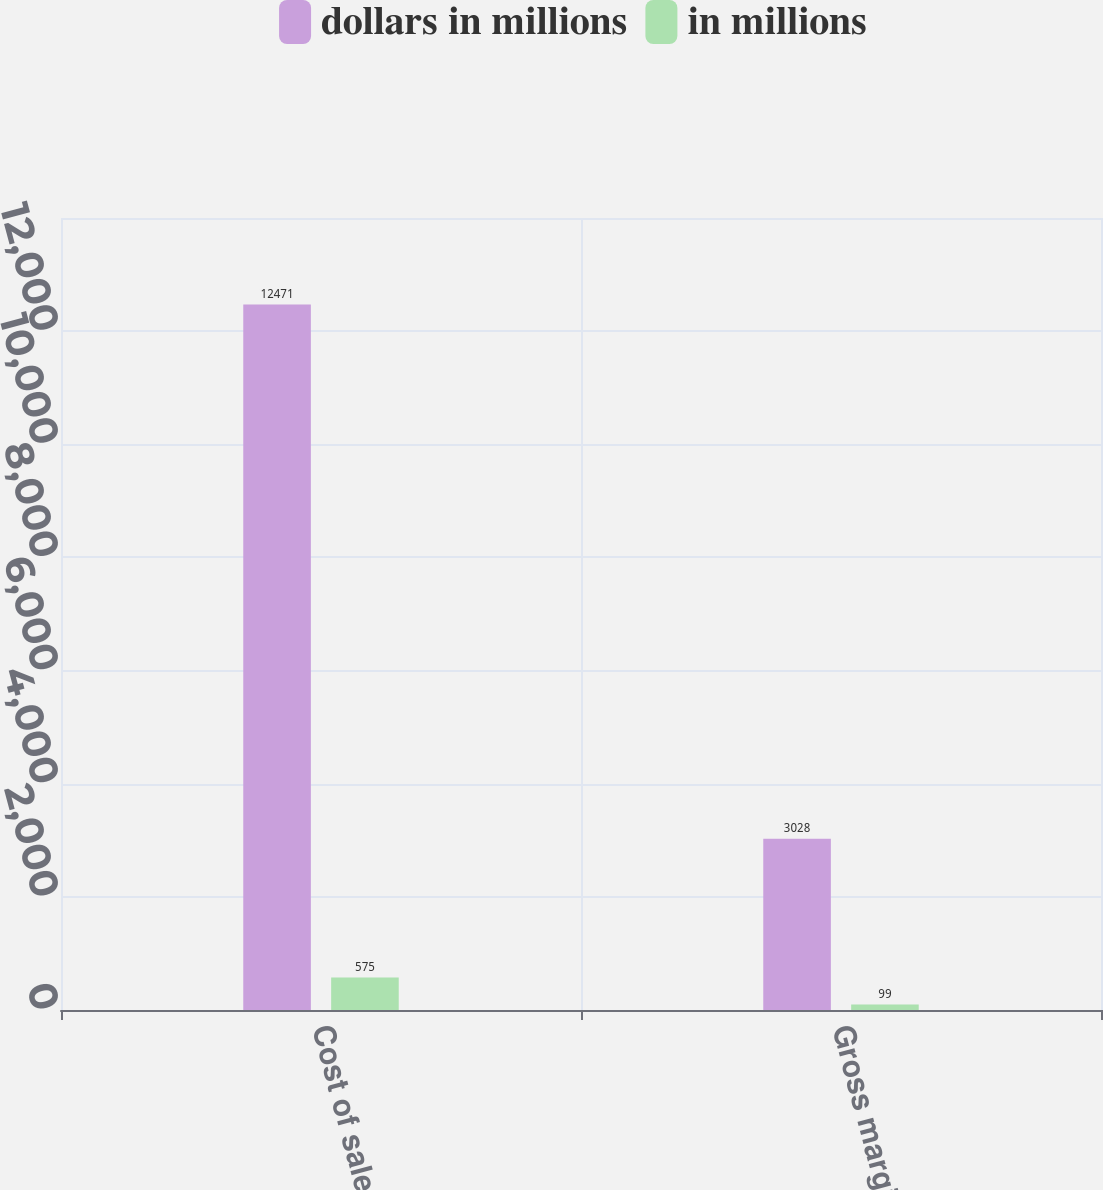Convert chart to OTSL. <chart><loc_0><loc_0><loc_500><loc_500><stacked_bar_chart><ecel><fcel>Cost of sales<fcel>Gross margin<nl><fcel>dollars in millions<fcel>12471<fcel>3028<nl><fcel>in millions<fcel>575<fcel>99<nl></chart> 